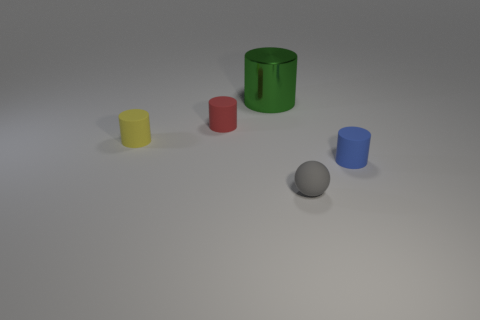Are there any other things that have the same material as the large cylinder?
Your answer should be very brief. No. There is a blue thing that is the same shape as the yellow rubber object; what is its size?
Keep it short and to the point. Small. How many green metallic things are the same size as the blue cylinder?
Your answer should be compact. 0. What is the material of the blue thing?
Give a very brief answer. Rubber. Are there any tiny cylinders behind the yellow cylinder?
Your response must be concise. Yes. Are there fewer red rubber cylinders to the right of the small gray thing than tiny cylinders to the left of the blue rubber cylinder?
Your answer should be compact. Yes. There is a matte cylinder that is right of the metal thing; what is its size?
Keep it short and to the point. Small. Is there a gray sphere made of the same material as the red cylinder?
Your response must be concise. Yes. Are the small yellow cylinder and the big thing made of the same material?
Keep it short and to the point. No. There is a sphere that is the same size as the blue rubber cylinder; what is its color?
Your response must be concise. Gray. 